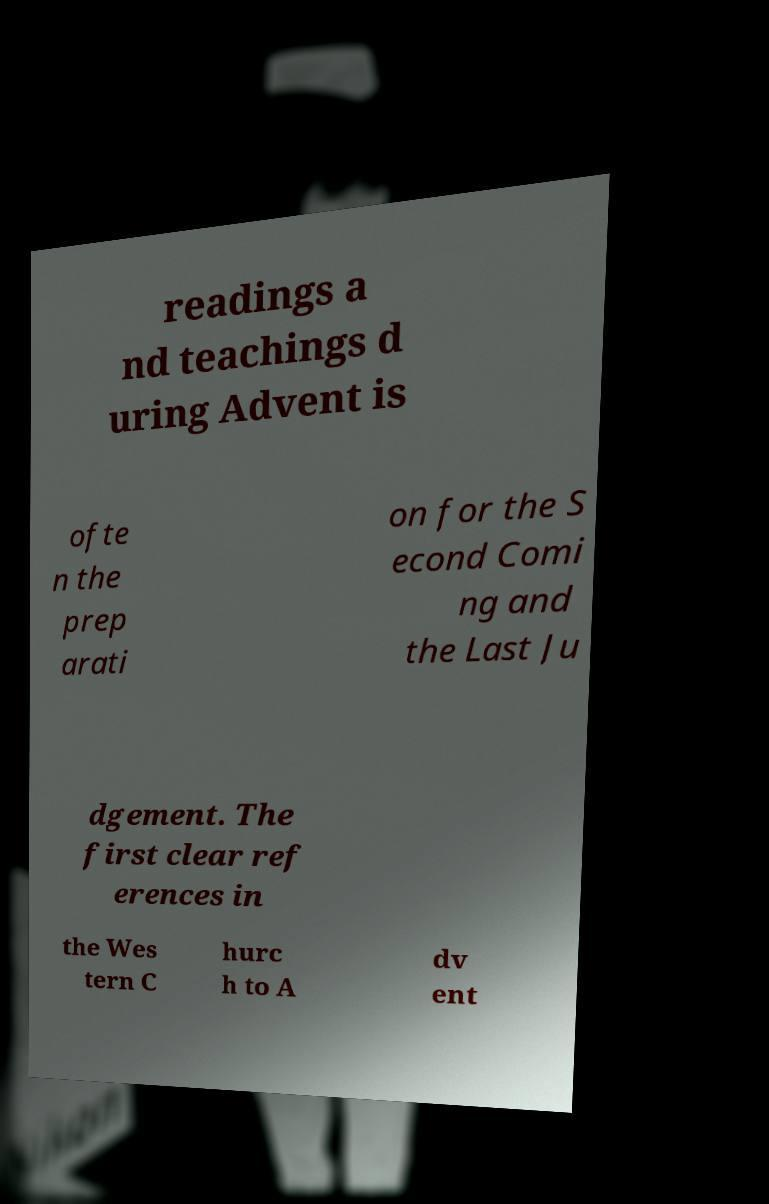Please identify and transcribe the text found in this image. readings a nd teachings d uring Advent is ofte n the prep arati on for the S econd Comi ng and the Last Ju dgement. The first clear ref erences in the Wes tern C hurc h to A dv ent 